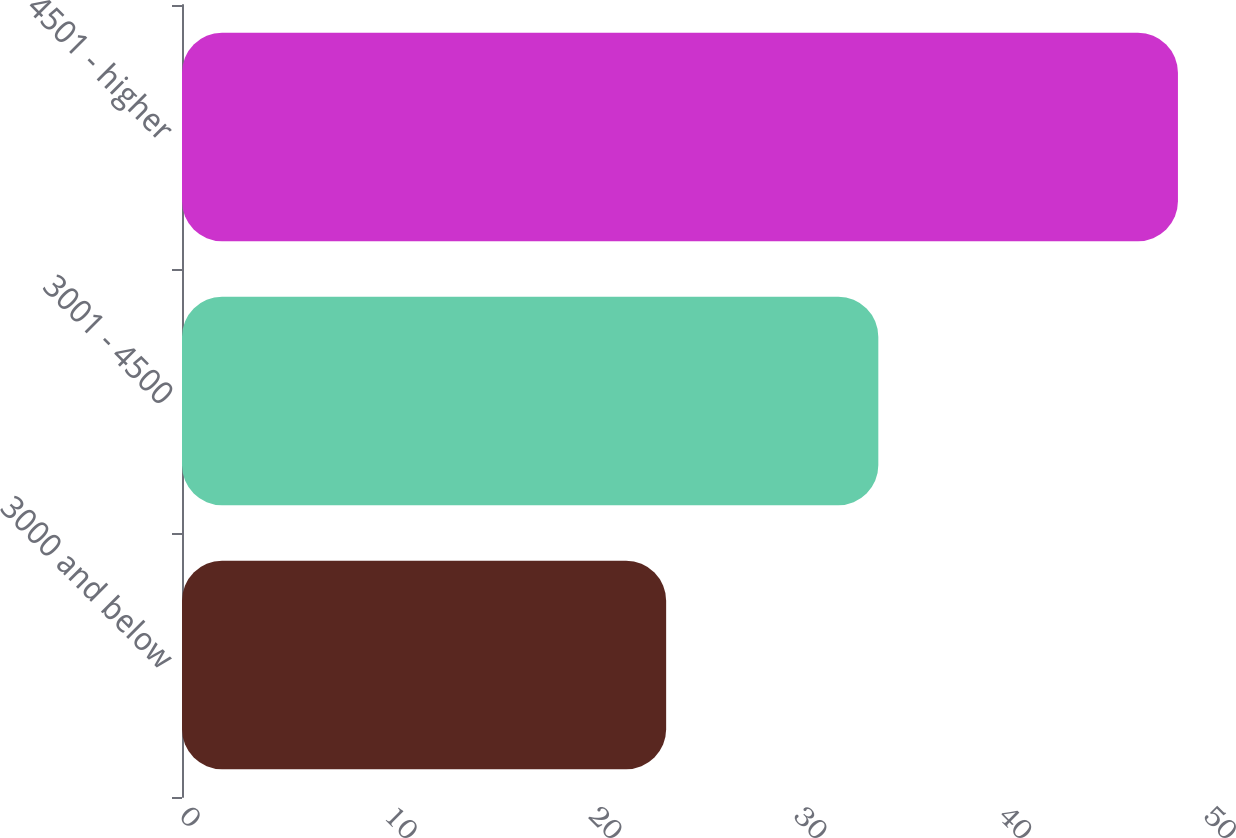<chart> <loc_0><loc_0><loc_500><loc_500><bar_chart><fcel>3000 and below<fcel>3001 - 4500<fcel>4501 - higher<nl><fcel>23.64<fcel>34<fcel>48.63<nl></chart> 